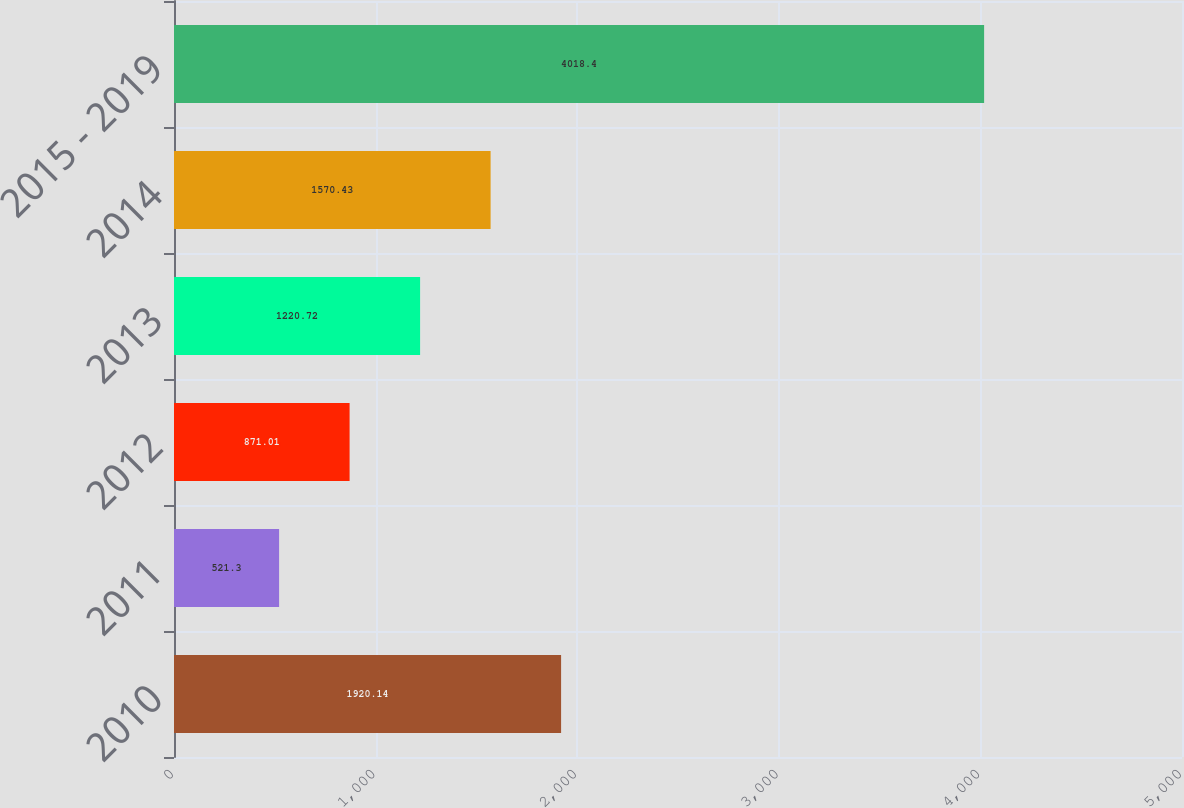Convert chart. <chart><loc_0><loc_0><loc_500><loc_500><bar_chart><fcel>2010<fcel>2011<fcel>2012<fcel>2013<fcel>2014<fcel>2015 - 2019<nl><fcel>1920.14<fcel>521.3<fcel>871.01<fcel>1220.72<fcel>1570.43<fcel>4018.4<nl></chart> 